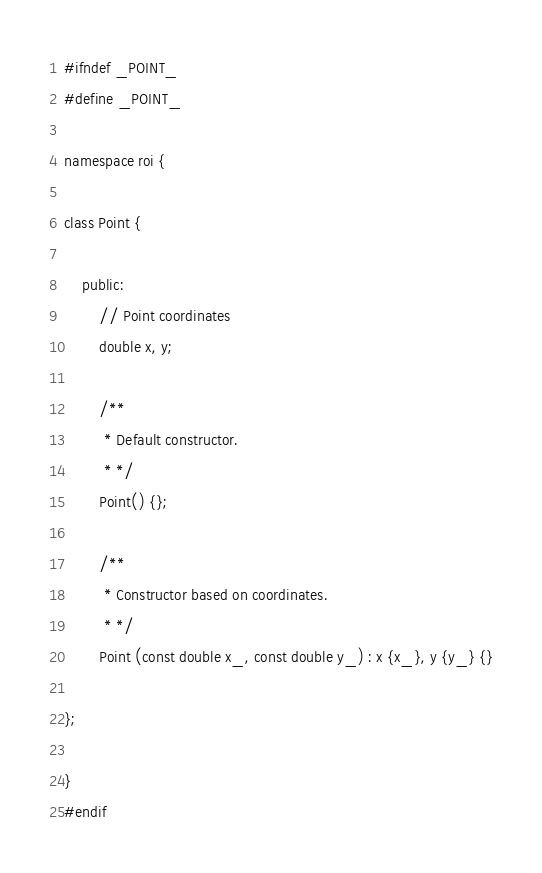Convert code to text. <code><loc_0><loc_0><loc_500><loc_500><_C_>#ifndef _POINT_
#define _POINT_

namespace roi {

class Point {

	public:
		// Point coordinates
		double x, y;		

		/**
		 * Default constructor.
		 * */
		Point() {};

		/**
		 * Constructor based on coordinates.
		 * */
		Point (const double x_, const double y_) : x {x_}, y {y_} {}

};

}
#endif
</code> 